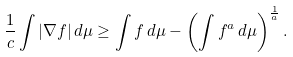Convert formula to latex. <formula><loc_0><loc_0><loc_500><loc_500>\frac { 1 } { c } \int | \nabla f | \, d \mu \geq \int f \, d \mu - \left ( \int f ^ { a } \, d \mu \right ) ^ { \frac { 1 } { a } } .</formula> 